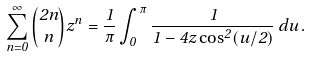Convert formula to latex. <formula><loc_0><loc_0><loc_500><loc_500>\sum _ { n = 0 } ^ { \infty } \binom { 2 n } n z ^ { n } = \frac { 1 } { \pi } \int _ { 0 } ^ { \pi } \frac { 1 } { 1 - 4 z \cos ^ { 2 } ( u / 2 ) } \, d u \, .</formula> 